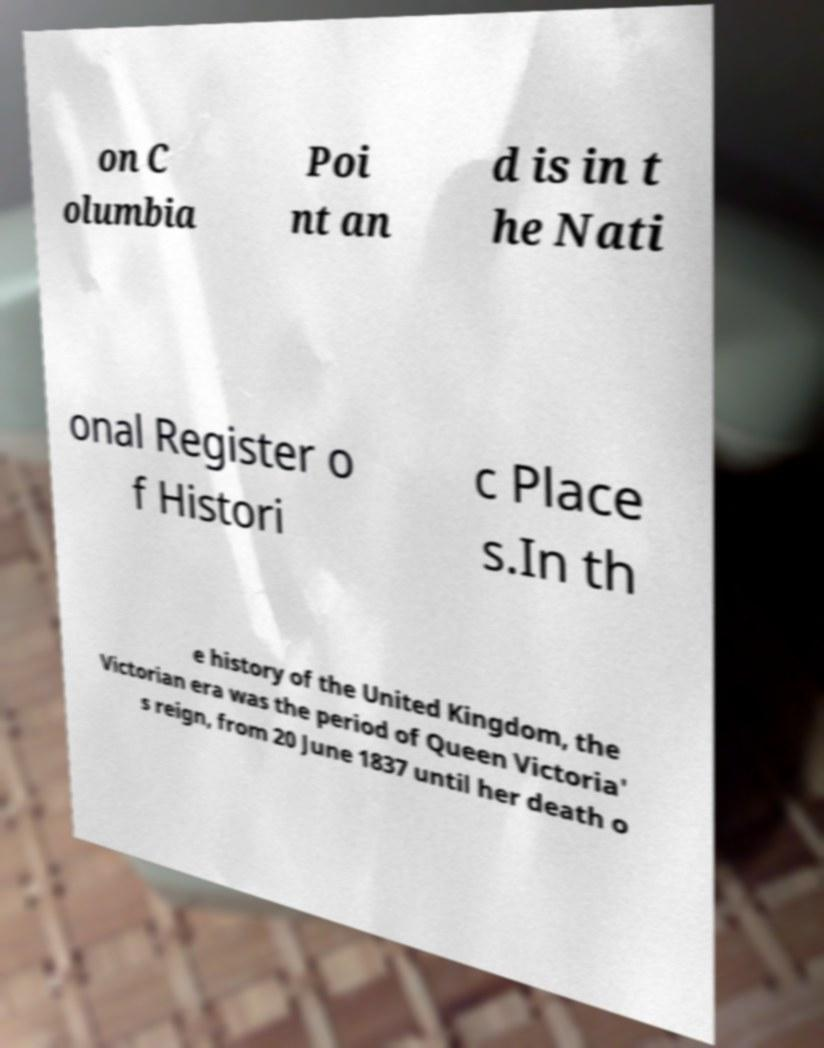Can you accurately transcribe the text from the provided image for me? on C olumbia Poi nt an d is in t he Nati onal Register o f Histori c Place s.In th e history of the United Kingdom, the Victorian era was the period of Queen Victoria' s reign, from 20 June 1837 until her death o 